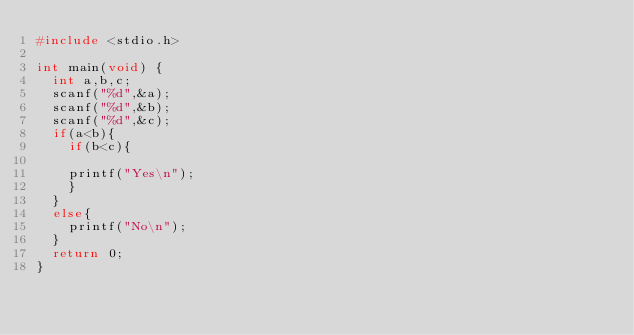<code> <loc_0><loc_0><loc_500><loc_500><_C_>#include <stdio.h>

int main(void) {
	int a,b,c;
	scanf("%d",&a);
	scanf("%d",&b);
	scanf("%d",&c);
	if(a<b){
		if(b<c){
	
		printf("Yes\n");
		}
	}
	else{
		printf("No\n");
	}
	return 0;
}</code> 